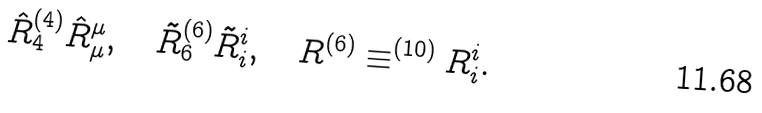<formula> <loc_0><loc_0><loc_500><loc_500>\hat { R } _ { 4 } ^ { ( 4 ) } \hat { R } _ { \mu } ^ { \mu } , \quad \tilde { R } _ { 6 } ^ { ( 6 ) } \tilde { R } _ { i } ^ { i } , \quad R ^ { ( 6 ) } \equiv ^ { ( 1 0 ) } R _ { i } ^ { i } .</formula> 